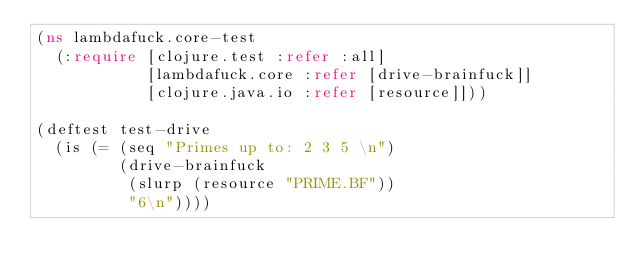<code> <loc_0><loc_0><loc_500><loc_500><_Clojure_>(ns lambdafuck.core-test
  (:require [clojure.test :refer :all]
            [lambdafuck.core :refer [drive-brainfuck]]
            [clojure.java.io :refer [resource]]))

(deftest test-drive
  (is (= (seq "Primes up to: 2 3 5 \n")
         (drive-brainfuck
          (slurp (resource "PRIME.BF"))
          "6\n"))))
</code> 